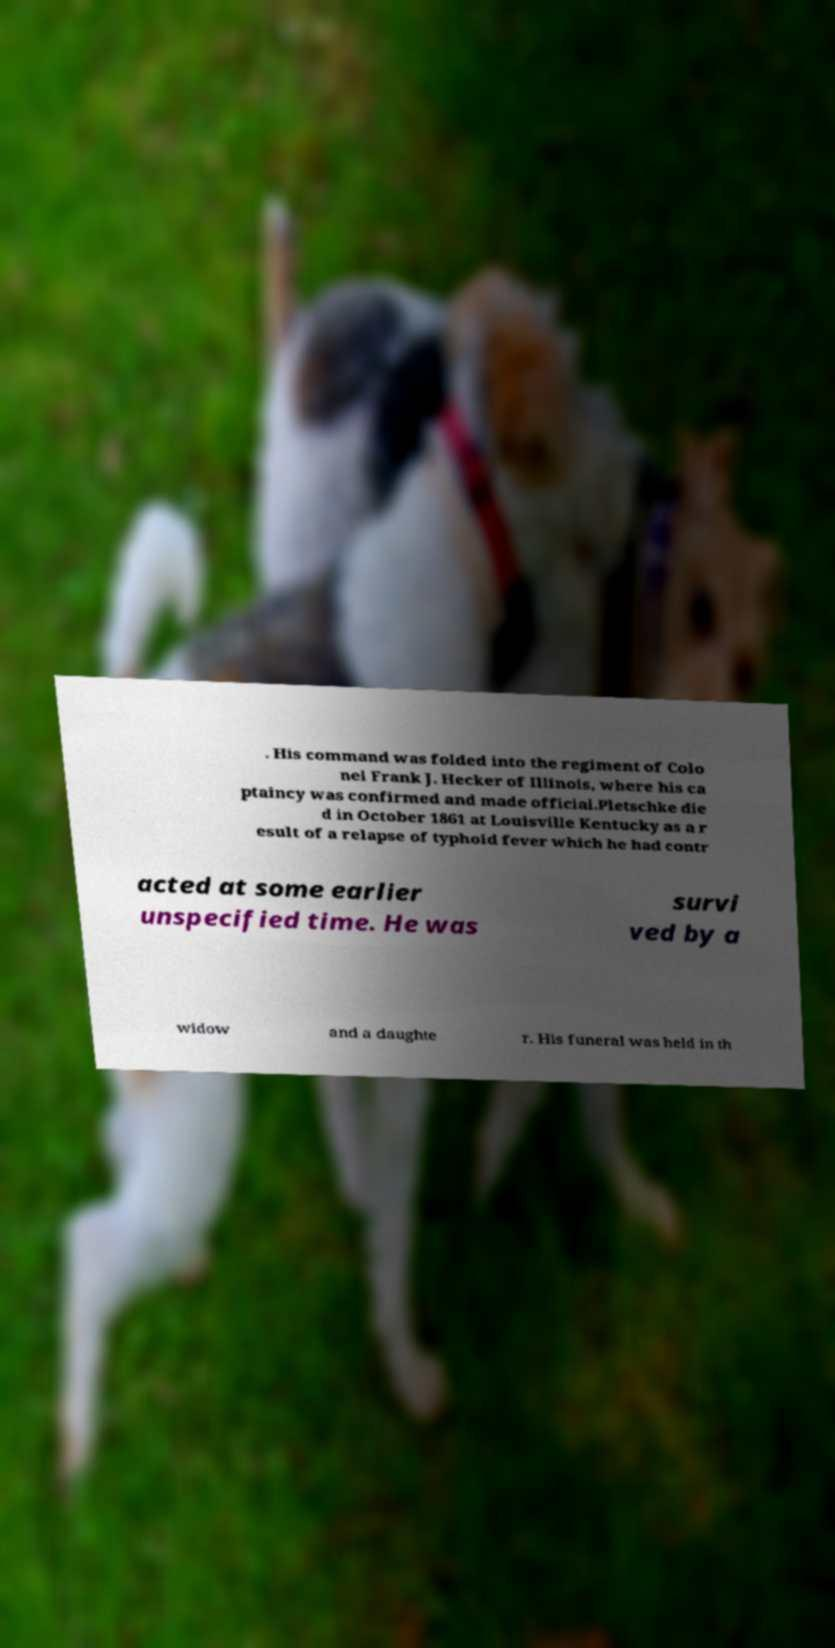For documentation purposes, I need the text within this image transcribed. Could you provide that? . His command was folded into the regiment of Colo nel Frank J. Hecker of Illinois, where his ca ptaincy was confirmed and made official.Pletschke die d in October 1861 at Louisville Kentucky as a r esult of a relapse of typhoid fever which he had contr acted at some earlier unspecified time. He was survi ved by a widow and a daughte r. His funeral was held in th 